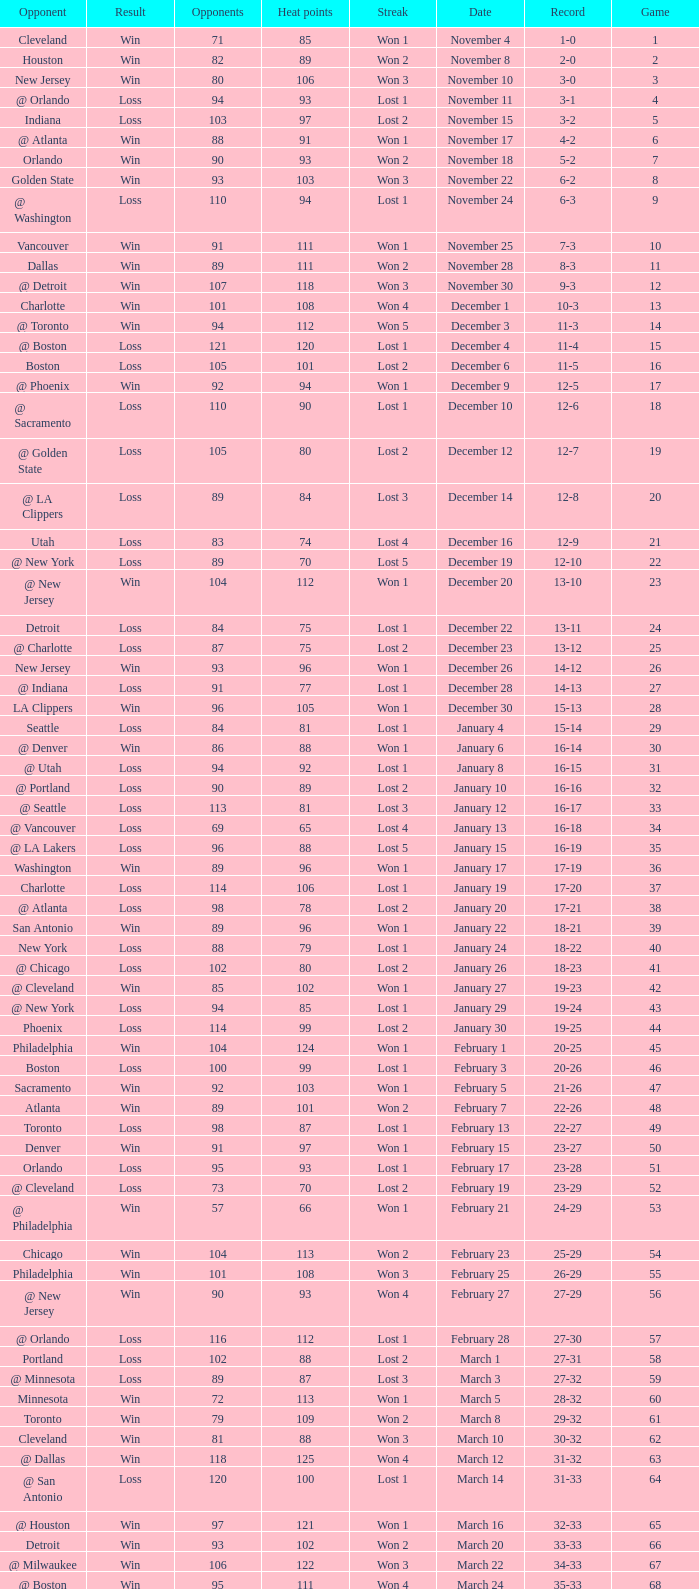What is the highest Game, when Opponents is less than 80, and when Record is "1-0"? 1.0. 